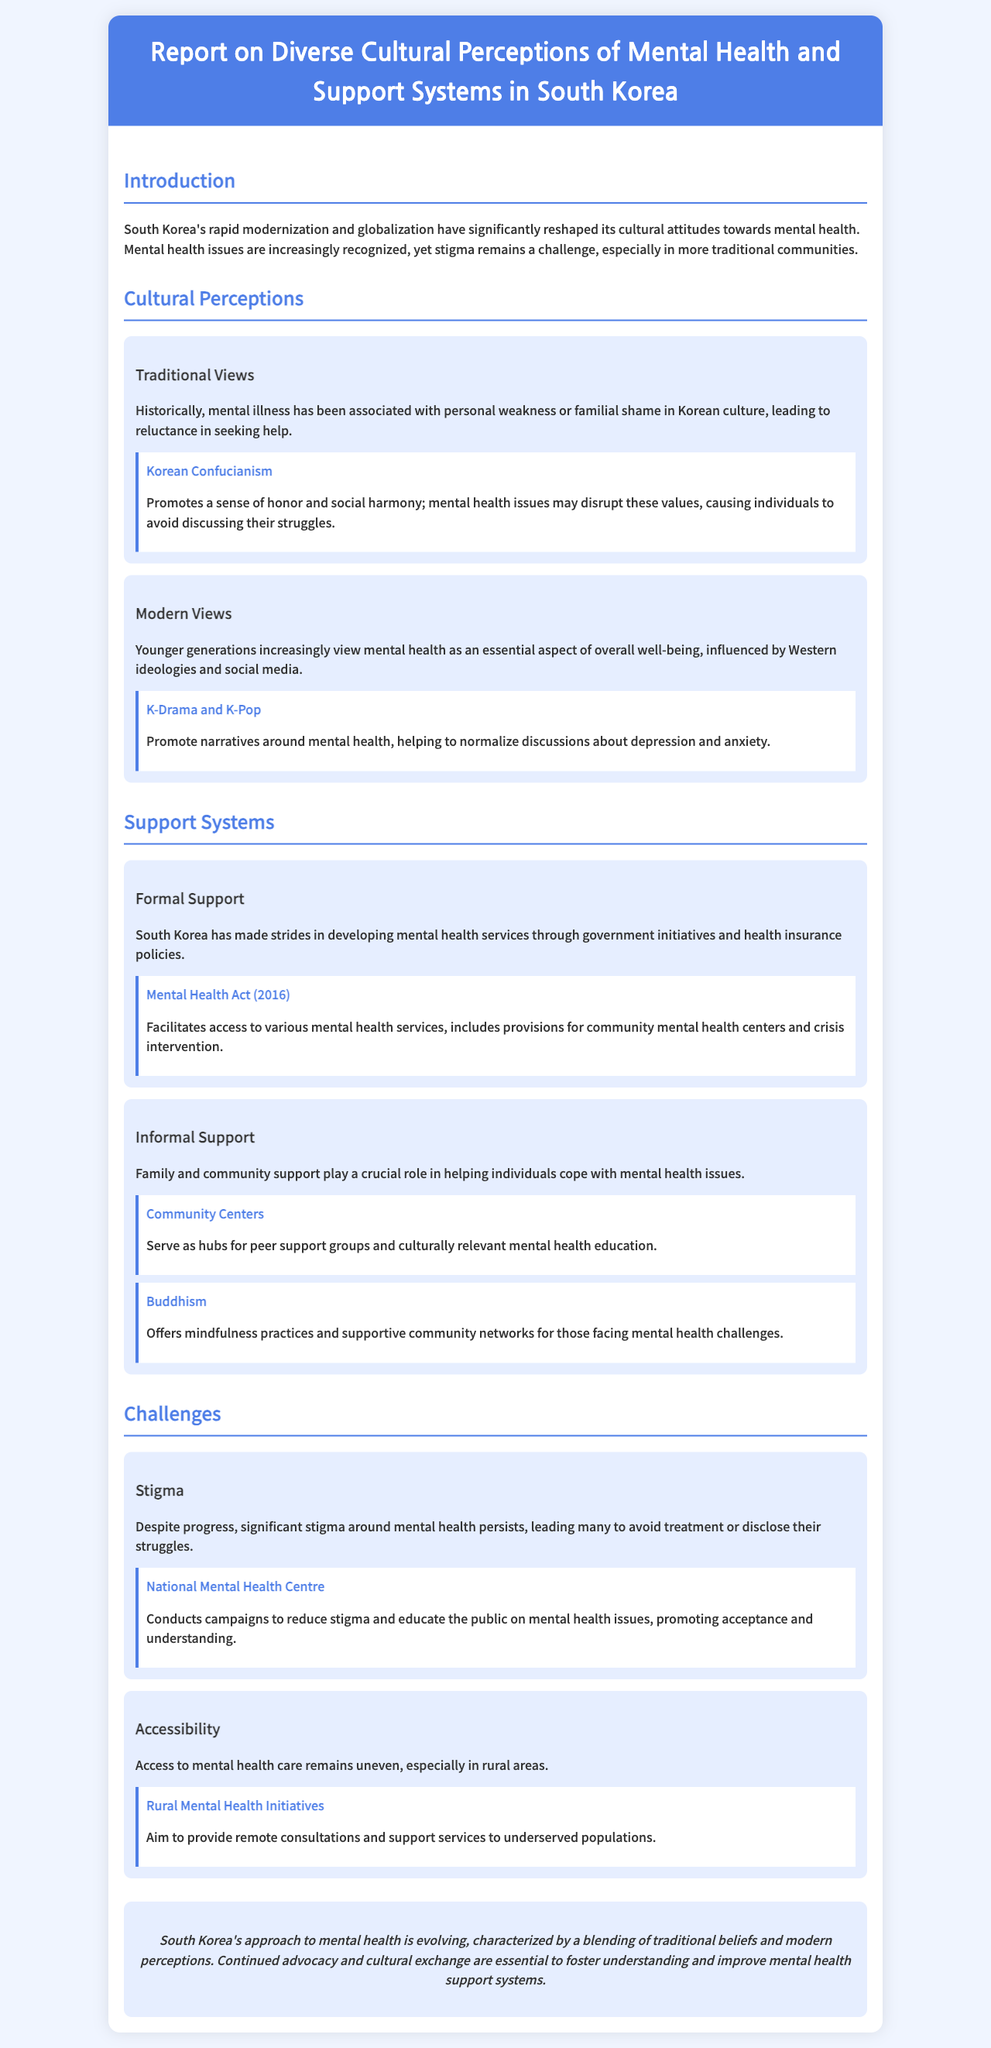What is the title of the report? The title of the report is found at the top of the document, which states the purpose of the content.
Answer: Report on Diverse Cultural Perceptions of Mental Health and Support Systems in South Korea What year was the Mental Health Act enacted? The Mental Health Act is mentioned in the document along with its enactment year to highlight a significant development in mental health services.
Answer: 2016 What cultural belief is associated with personal weakness in the document? The document references traditional views that link mental illness to a specific cultural perspective that impacts help-seeking behavior.
Answer: Korean Confucianism What role do community centers play in mental health support? The document describes the function of community centers in providing assistance and education related to mental health within the community.
Answer: Serve as hubs for peer support groups and culturally relevant mental health education What is a major challenge mentioned regarding mental health care in South Korea? The document outlines key challenges in the mental health system, focusing on public perceptions and availability of services.
Answer: Stigma How do younger generations perceive mental health differently than older generations? The report notes a shift in views among younger individuals, reflecting their changing attitudes towards mental health influenced by new factors.
Answer: Essential aspect of overall well-being What initiative is aimed at addressing rural mental health accessibility? The document specifies a particular initiative that targets mental health care access for those living outside urban areas.
Answer: Rural Mental Health Initiatives What does the conclusion emphasize about South Korea's approach to mental health? The conclusion summarizes the document's key takeaways regarding the interplay of traditional and modern influences on mental health perceptions.
Answer: Evolving, characterized by a blending of traditional beliefs and modern perceptions 